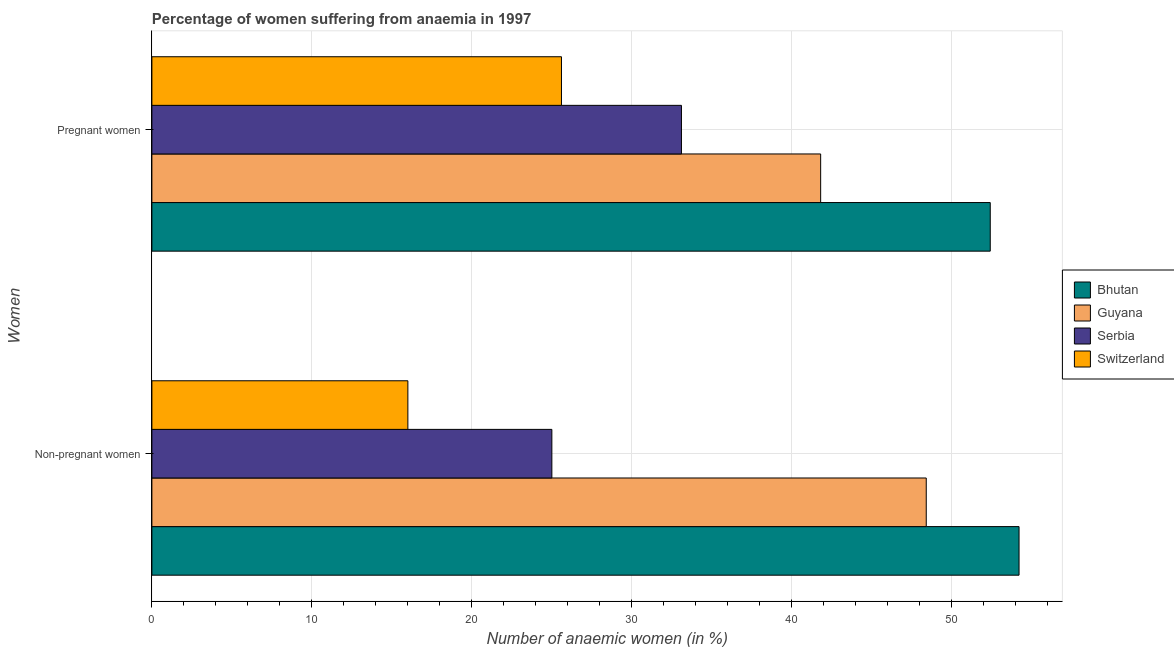How many groups of bars are there?
Your answer should be very brief. 2. Are the number of bars per tick equal to the number of legend labels?
Your answer should be compact. Yes. Are the number of bars on each tick of the Y-axis equal?
Provide a succinct answer. Yes. How many bars are there on the 2nd tick from the top?
Offer a very short reply. 4. What is the label of the 1st group of bars from the top?
Provide a short and direct response. Pregnant women. What is the percentage of pregnant anaemic women in Guyana?
Give a very brief answer. 41.8. Across all countries, what is the maximum percentage of non-pregnant anaemic women?
Your answer should be very brief. 54.2. Across all countries, what is the minimum percentage of non-pregnant anaemic women?
Offer a very short reply. 16. In which country was the percentage of pregnant anaemic women maximum?
Ensure brevity in your answer.  Bhutan. In which country was the percentage of pregnant anaemic women minimum?
Offer a very short reply. Switzerland. What is the total percentage of pregnant anaemic women in the graph?
Ensure brevity in your answer.  152.9. What is the difference between the percentage of pregnant anaemic women in Guyana and that in Bhutan?
Your answer should be compact. -10.6. What is the difference between the percentage of pregnant anaemic women in Switzerland and the percentage of non-pregnant anaemic women in Guyana?
Your response must be concise. -22.8. What is the average percentage of non-pregnant anaemic women per country?
Your response must be concise. 35.9. What is the difference between the percentage of pregnant anaemic women and percentage of non-pregnant anaemic women in Guyana?
Offer a terse response. -6.6. In how many countries, is the percentage of pregnant anaemic women greater than 6 %?
Offer a very short reply. 4. What is the ratio of the percentage of pregnant anaemic women in Serbia to that in Switzerland?
Make the answer very short. 1.29. In how many countries, is the percentage of non-pregnant anaemic women greater than the average percentage of non-pregnant anaemic women taken over all countries?
Provide a succinct answer. 2. What does the 3rd bar from the top in Pregnant women represents?
Provide a short and direct response. Guyana. What does the 4th bar from the bottom in Non-pregnant women represents?
Provide a succinct answer. Switzerland. How many bars are there?
Offer a very short reply. 8. Does the graph contain grids?
Offer a very short reply. Yes. What is the title of the graph?
Your response must be concise. Percentage of women suffering from anaemia in 1997. Does "Azerbaijan" appear as one of the legend labels in the graph?
Provide a succinct answer. No. What is the label or title of the X-axis?
Provide a succinct answer. Number of anaemic women (in %). What is the label or title of the Y-axis?
Your answer should be compact. Women. What is the Number of anaemic women (in %) of Bhutan in Non-pregnant women?
Your answer should be very brief. 54.2. What is the Number of anaemic women (in %) in Guyana in Non-pregnant women?
Keep it short and to the point. 48.4. What is the Number of anaemic women (in %) in Switzerland in Non-pregnant women?
Provide a succinct answer. 16. What is the Number of anaemic women (in %) in Bhutan in Pregnant women?
Your answer should be very brief. 52.4. What is the Number of anaemic women (in %) of Guyana in Pregnant women?
Ensure brevity in your answer.  41.8. What is the Number of anaemic women (in %) in Serbia in Pregnant women?
Your answer should be compact. 33.1. What is the Number of anaemic women (in %) in Switzerland in Pregnant women?
Your response must be concise. 25.6. Across all Women, what is the maximum Number of anaemic women (in %) of Bhutan?
Make the answer very short. 54.2. Across all Women, what is the maximum Number of anaemic women (in %) in Guyana?
Provide a succinct answer. 48.4. Across all Women, what is the maximum Number of anaemic women (in %) of Serbia?
Your answer should be very brief. 33.1. Across all Women, what is the maximum Number of anaemic women (in %) in Switzerland?
Keep it short and to the point. 25.6. Across all Women, what is the minimum Number of anaemic women (in %) in Bhutan?
Your response must be concise. 52.4. Across all Women, what is the minimum Number of anaemic women (in %) of Guyana?
Give a very brief answer. 41.8. Across all Women, what is the minimum Number of anaemic women (in %) of Switzerland?
Give a very brief answer. 16. What is the total Number of anaemic women (in %) in Bhutan in the graph?
Offer a very short reply. 106.6. What is the total Number of anaemic women (in %) in Guyana in the graph?
Ensure brevity in your answer.  90.2. What is the total Number of anaemic women (in %) in Serbia in the graph?
Offer a terse response. 58.1. What is the total Number of anaemic women (in %) of Switzerland in the graph?
Your answer should be very brief. 41.6. What is the difference between the Number of anaemic women (in %) in Bhutan in Non-pregnant women and that in Pregnant women?
Provide a short and direct response. 1.8. What is the difference between the Number of anaemic women (in %) of Guyana in Non-pregnant women and that in Pregnant women?
Your answer should be very brief. 6.6. What is the difference between the Number of anaemic women (in %) in Serbia in Non-pregnant women and that in Pregnant women?
Your answer should be compact. -8.1. What is the difference between the Number of anaemic women (in %) in Bhutan in Non-pregnant women and the Number of anaemic women (in %) in Guyana in Pregnant women?
Your response must be concise. 12.4. What is the difference between the Number of anaemic women (in %) in Bhutan in Non-pregnant women and the Number of anaemic women (in %) in Serbia in Pregnant women?
Offer a terse response. 21.1. What is the difference between the Number of anaemic women (in %) of Bhutan in Non-pregnant women and the Number of anaemic women (in %) of Switzerland in Pregnant women?
Provide a short and direct response. 28.6. What is the difference between the Number of anaemic women (in %) of Guyana in Non-pregnant women and the Number of anaemic women (in %) of Serbia in Pregnant women?
Provide a short and direct response. 15.3. What is the difference between the Number of anaemic women (in %) of Guyana in Non-pregnant women and the Number of anaemic women (in %) of Switzerland in Pregnant women?
Your answer should be compact. 22.8. What is the average Number of anaemic women (in %) in Bhutan per Women?
Offer a terse response. 53.3. What is the average Number of anaemic women (in %) of Guyana per Women?
Give a very brief answer. 45.1. What is the average Number of anaemic women (in %) of Serbia per Women?
Your answer should be compact. 29.05. What is the average Number of anaemic women (in %) in Switzerland per Women?
Give a very brief answer. 20.8. What is the difference between the Number of anaemic women (in %) in Bhutan and Number of anaemic women (in %) in Guyana in Non-pregnant women?
Offer a terse response. 5.8. What is the difference between the Number of anaemic women (in %) of Bhutan and Number of anaemic women (in %) of Serbia in Non-pregnant women?
Offer a very short reply. 29.2. What is the difference between the Number of anaemic women (in %) of Bhutan and Number of anaemic women (in %) of Switzerland in Non-pregnant women?
Give a very brief answer. 38.2. What is the difference between the Number of anaemic women (in %) of Guyana and Number of anaemic women (in %) of Serbia in Non-pregnant women?
Keep it short and to the point. 23.4. What is the difference between the Number of anaemic women (in %) of Guyana and Number of anaemic women (in %) of Switzerland in Non-pregnant women?
Offer a terse response. 32.4. What is the difference between the Number of anaemic women (in %) in Serbia and Number of anaemic women (in %) in Switzerland in Non-pregnant women?
Keep it short and to the point. 9. What is the difference between the Number of anaemic women (in %) in Bhutan and Number of anaemic women (in %) in Guyana in Pregnant women?
Offer a very short reply. 10.6. What is the difference between the Number of anaemic women (in %) in Bhutan and Number of anaemic women (in %) in Serbia in Pregnant women?
Offer a terse response. 19.3. What is the difference between the Number of anaemic women (in %) in Bhutan and Number of anaemic women (in %) in Switzerland in Pregnant women?
Offer a very short reply. 26.8. What is the ratio of the Number of anaemic women (in %) in Bhutan in Non-pregnant women to that in Pregnant women?
Your answer should be compact. 1.03. What is the ratio of the Number of anaemic women (in %) of Guyana in Non-pregnant women to that in Pregnant women?
Your response must be concise. 1.16. What is the ratio of the Number of anaemic women (in %) in Serbia in Non-pregnant women to that in Pregnant women?
Your answer should be compact. 0.76. What is the ratio of the Number of anaemic women (in %) of Switzerland in Non-pregnant women to that in Pregnant women?
Your answer should be very brief. 0.62. What is the difference between the highest and the second highest Number of anaemic women (in %) in Bhutan?
Your answer should be very brief. 1.8. What is the difference between the highest and the second highest Number of anaemic women (in %) of Serbia?
Your response must be concise. 8.1. What is the difference between the highest and the lowest Number of anaemic women (in %) in Bhutan?
Provide a short and direct response. 1.8. What is the difference between the highest and the lowest Number of anaemic women (in %) of Serbia?
Your answer should be very brief. 8.1. 